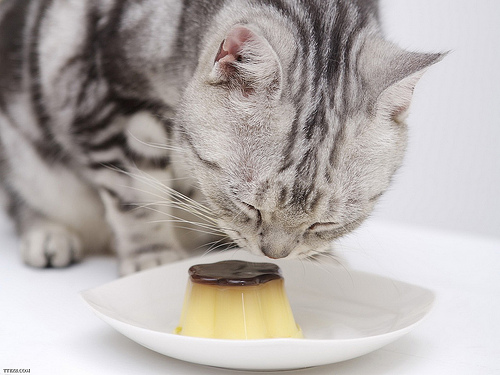Describe the expression on the cat's face as it interacts with the custard. The cat appears curious and focused, with its nose slightly touching the custard's glistening surface, possibly exploring the unfamiliar item with subtle interest. Can you comment on the cat's whiskers and their positioning? The cat's whiskers are forward-facing, indicating a heightened sense of interest and investigation as it examines the custard closely. 